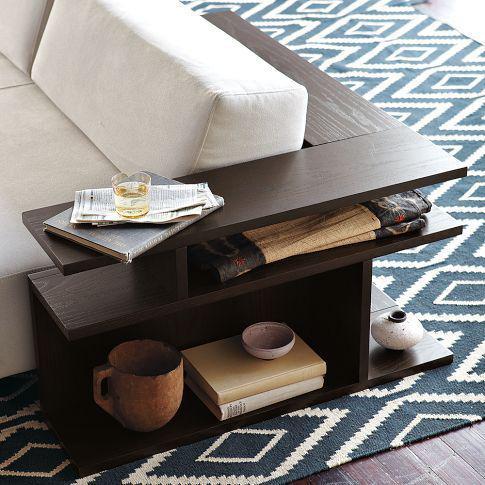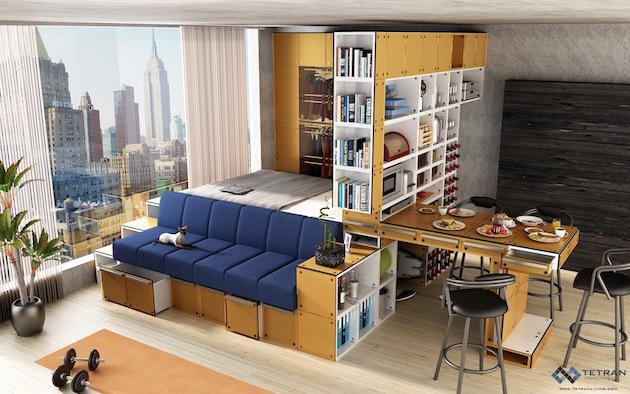The first image is the image on the left, the second image is the image on the right. Given the left and right images, does the statement "The left image shows a woodgrain shelving unit that wraps around the back and side of a couch, with two lamps on its top." hold true? Answer yes or no. No. The first image is the image on the left, the second image is the image on the right. Given the left and right images, does the statement "In at least one image there is a bookshelf couch with no more than three deep blue pillows." hold true? Answer yes or no. No. 